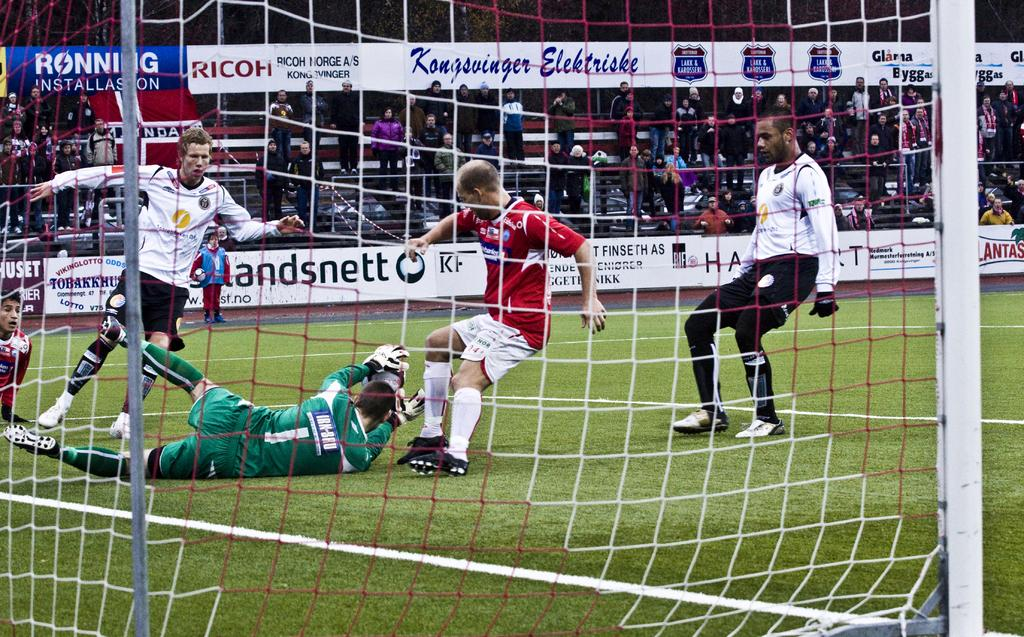<image>
Present a compact description of the photo's key features. A group of soccer players playing soccer with one of the ads in the stadiums saying Blandsnett 